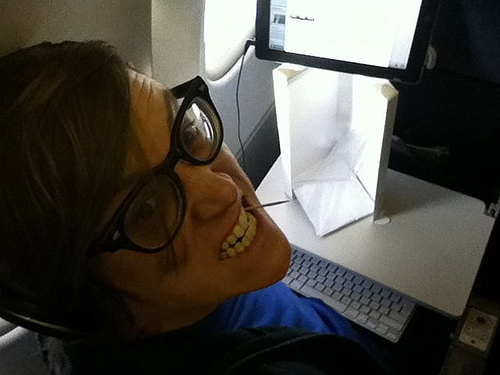If this was a scene in a movie, which genre would it belong to? This scene could belong to a science fiction or espionage thriller, where the character is working on a mission amid high-tech gadgets and secretive tasks. 